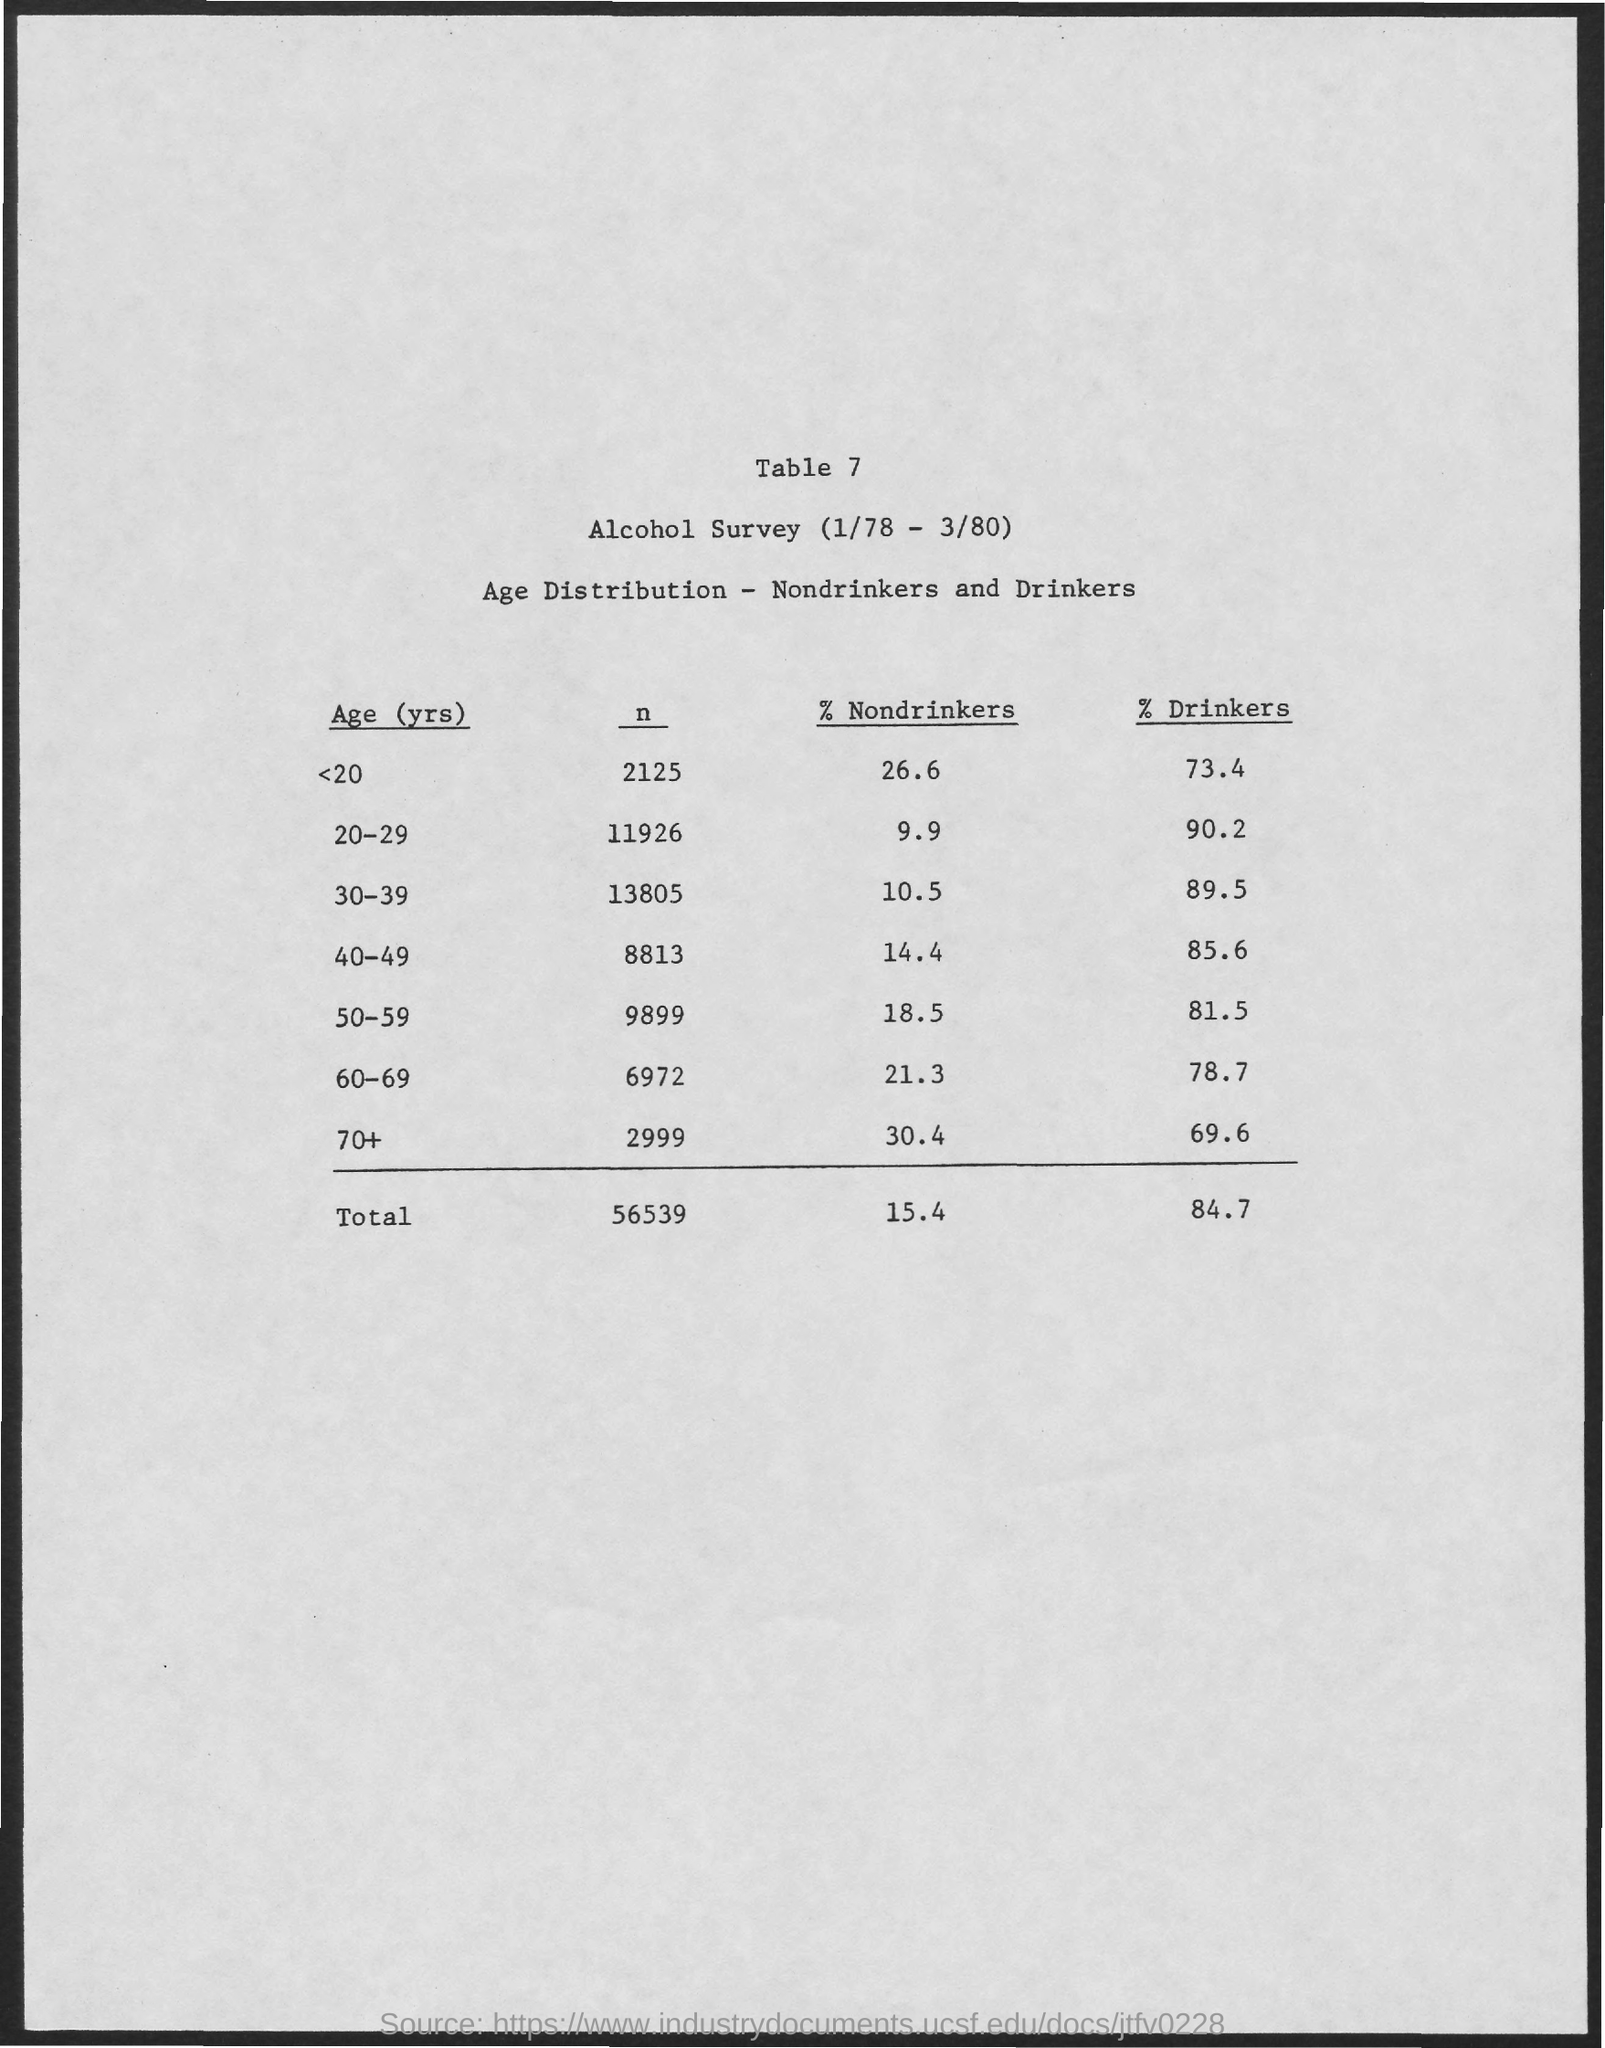Mention a couple of crucial points in this snapshot. The percentage of nondrinkers is particularly low in the age group of 20-29 years old. According to the survey, a significant proportion of individuals in the age group of 70 and above do not consume alcohol. According to the data, approximately 26.6% of individuals below the age of 20 are non-drinkers. I would like to request the table number, is it table 7? According to the data, a significant percentage of individuals in the age group of 20-29 are drinkers. 